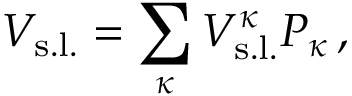Convert formula to latex. <formula><loc_0><loc_0><loc_500><loc_500>V _ { s . l . } = \sum _ { \kappa } V _ { s . l . } ^ { \kappa } P _ { \kappa } \, ,</formula> 